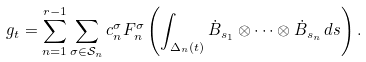<formula> <loc_0><loc_0><loc_500><loc_500>g _ { t } = \sum _ { n = 1 } ^ { r - 1 } \sum _ { \sigma \in \mathcal { S } _ { n } } c ^ { \sigma } _ { n } F ^ { \sigma } _ { n } \left ( \int _ { \Delta _ { n } ( t ) } \dot { B } _ { s _ { 1 } } \otimes \cdots \otimes \dot { B } _ { s _ { n } } \, d s \right ) .</formula> 